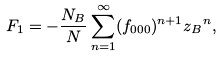<formula> <loc_0><loc_0><loc_500><loc_500>F _ { 1 } = - \frac { N _ { B } } { N } \sum _ { n = 1 } ^ { \infty } ( f _ { 0 0 0 } ) ^ { n + 1 } { z _ { B } } ^ { n } ,</formula> 